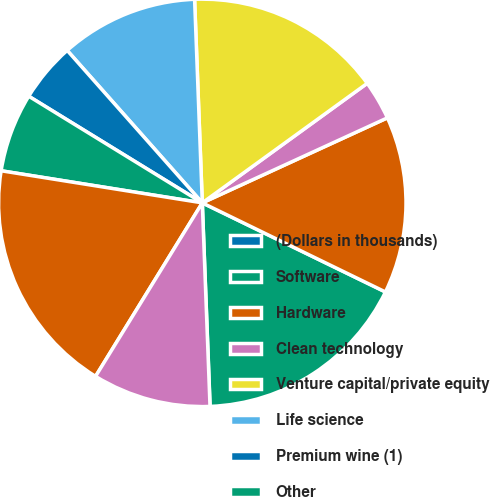Convert chart to OTSL. <chart><loc_0><loc_0><loc_500><loc_500><pie_chart><fcel>(Dollars in thousands)<fcel>Software<fcel>Hardware<fcel>Clean technology<fcel>Venture capital/private equity<fcel>Life science<fcel>Premium wine (1)<fcel>Other<fcel>Commercial loans (2)<fcel>Consumer loans (3)<nl><fcel>0.01%<fcel>17.18%<fcel>14.06%<fcel>3.13%<fcel>15.62%<fcel>10.94%<fcel>4.69%<fcel>6.25%<fcel>18.74%<fcel>9.38%<nl></chart> 